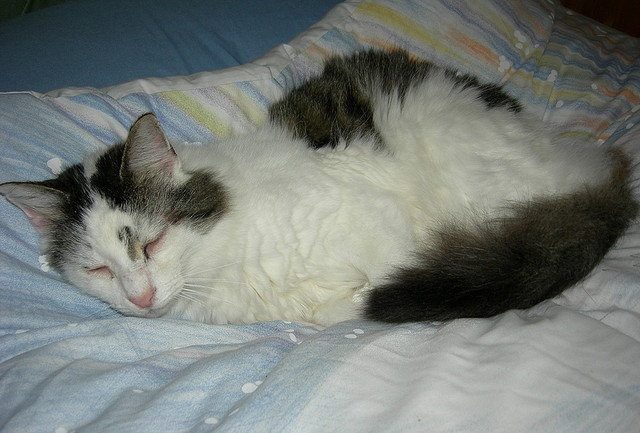Describe the objects in this image and their specific colors. I can see bed in black, darkgray, and gray tones and cat in black, darkgray, gray, and lightgray tones in this image. 